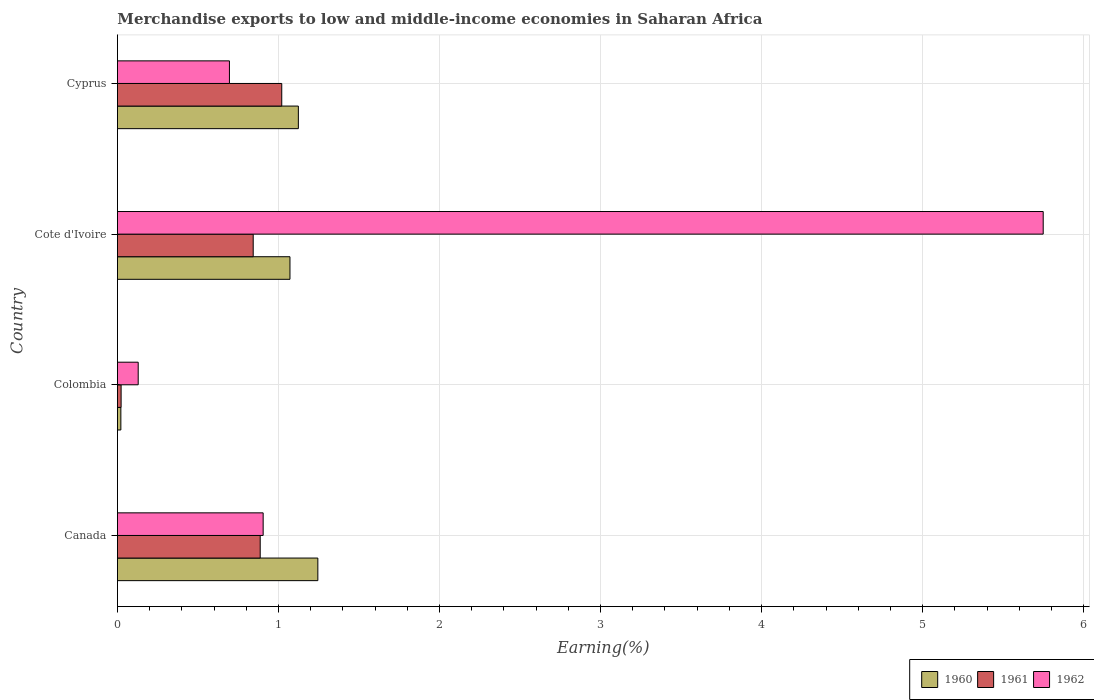Are the number of bars per tick equal to the number of legend labels?
Provide a short and direct response. Yes. Are the number of bars on each tick of the Y-axis equal?
Provide a succinct answer. Yes. How many bars are there on the 3rd tick from the bottom?
Keep it short and to the point. 3. What is the label of the 2nd group of bars from the top?
Your answer should be very brief. Cote d'Ivoire. What is the percentage of amount earned from merchandise exports in 1962 in Cote d'Ivoire?
Make the answer very short. 5.75. Across all countries, what is the maximum percentage of amount earned from merchandise exports in 1960?
Provide a short and direct response. 1.24. Across all countries, what is the minimum percentage of amount earned from merchandise exports in 1960?
Your answer should be very brief. 0.02. In which country was the percentage of amount earned from merchandise exports in 1962 minimum?
Provide a succinct answer. Colombia. What is the total percentage of amount earned from merchandise exports in 1961 in the graph?
Keep it short and to the point. 2.77. What is the difference between the percentage of amount earned from merchandise exports in 1960 in Canada and that in Colombia?
Your answer should be very brief. 1.22. What is the difference between the percentage of amount earned from merchandise exports in 1962 in Canada and the percentage of amount earned from merchandise exports in 1960 in Cote d'Ivoire?
Your response must be concise. -0.17. What is the average percentage of amount earned from merchandise exports in 1960 per country?
Provide a short and direct response. 0.87. What is the difference between the percentage of amount earned from merchandise exports in 1961 and percentage of amount earned from merchandise exports in 1960 in Canada?
Make the answer very short. -0.36. In how many countries, is the percentage of amount earned from merchandise exports in 1960 greater than 1 %?
Provide a succinct answer. 3. What is the ratio of the percentage of amount earned from merchandise exports in 1961 in Cote d'Ivoire to that in Cyprus?
Offer a terse response. 0.83. What is the difference between the highest and the second highest percentage of amount earned from merchandise exports in 1962?
Your answer should be compact. 4.84. What is the difference between the highest and the lowest percentage of amount earned from merchandise exports in 1960?
Your response must be concise. 1.22. In how many countries, is the percentage of amount earned from merchandise exports in 1961 greater than the average percentage of amount earned from merchandise exports in 1961 taken over all countries?
Offer a very short reply. 3. What does the 3rd bar from the top in Canada represents?
Provide a short and direct response. 1960. Is it the case that in every country, the sum of the percentage of amount earned from merchandise exports in 1961 and percentage of amount earned from merchandise exports in 1962 is greater than the percentage of amount earned from merchandise exports in 1960?
Provide a short and direct response. Yes. Are the values on the major ticks of X-axis written in scientific E-notation?
Keep it short and to the point. No. Does the graph contain grids?
Your answer should be compact. Yes. Where does the legend appear in the graph?
Your answer should be compact. Bottom right. What is the title of the graph?
Your answer should be very brief. Merchandise exports to low and middle-income economies in Saharan Africa. What is the label or title of the X-axis?
Offer a terse response. Earning(%). What is the label or title of the Y-axis?
Your answer should be compact. Country. What is the Earning(%) in 1960 in Canada?
Make the answer very short. 1.24. What is the Earning(%) in 1961 in Canada?
Ensure brevity in your answer.  0.89. What is the Earning(%) in 1962 in Canada?
Make the answer very short. 0.9. What is the Earning(%) in 1960 in Colombia?
Provide a succinct answer. 0.02. What is the Earning(%) in 1961 in Colombia?
Offer a very short reply. 0.02. What is the Earning(%) in 1962 in Colombia?
Provide a succinct answer. 0.13. What is the Earning(%) of 1960 in Cote d'Ivoire?
Your response must be concise. 1.07. What is the Earning(%) in 1961 in Cote d'Ivoire?
Keep it short and to the point. 0.84. What is the Earning(%) of 1962 in Cote d'Ivoire?
Offer a very short reply. 5.75. What is the Earning(%) of 1960 in Cyprus?
Make the answer very short. 1.12. What is the Earning(%) in 1961 in Cyprus?
Ensure brevity in your answer.  1.02. What is the Earning(%) in 1962 in Cyprus?
Keep it short and to the point. 0.7. Across all countries, what is the maximum Earning(%) in 1960?
Your answer should be compact. 1.24. Across all countries, what is the maximum Earning(%) of 1961?
Provide a succinct answer. 1.02. Across all countries, what is the maximum Earning(%) in 1962?
Make the answer very short. 5.75. Across all countries, what is the minimum Earning(%) in 1960?
Give a very brief answer. 0.02. Across all countries, what is the minimum Earning(%) of 1961?
Give a very brief answer. 0.02. Across all countries, what is the minimum Earning(%) in 1962?
Offer a very short reply. 0.13. What is the total Earning(%) of 1960 in the graph?
Make the answer very short. 3.46. What is the total Earning(%) in 1961 in the graph?
Ensure brevity in your answer.  2.77. What is the total Earning(%) in 1962 in the graph?
Provide a succinct answer. 7.48. What is the difference between the Earning(%) of 1960 in Canada and that in Colombia?
Give a very brief answer. 1.22. What is the difference between the Earning(%) in 1961 in Canada and that in Colombia?
Offer a terse response. 0.86. What is the difference between the Earning(%) in 1962 in Canada and that in Colombia?
Your answer should be very brief. 0.78. What is the difference between the Earning(%) of 1960 in Canada and that in Cote d'Ivoire?
Provide a succinct answer. 0.17. What is the difference between the Earning(%) in 1961 in Canada and that in Cote d'Ivoire?
Keep it short and to the point. 0.04. What is the difference between the Earning(%) in 1962 in Canada and that in Cote d'Ivoire?
Give a very brief answer. -4.84. What is the difference between the Earning(%) of 1960 in Canada and that in Cyprus?
Offer a very short reply. 0.12. What is the difference between the Earning(%) of 1961 in Canada and that in Cyprus?
Provide a short and direct response. -0.13. What is the difference between the Earning(%) of 1962 in Canada and that in Cyprus?
Your answer should be compact. 0.21. What is the difference between the Earning(%) in 1960 in Colombia and that in Cote d'Ivoire?
Offer a terse response. -1.05. What is the difference between the Earning(%) of 1961 in Colombia and that in Cote d'Ivoire?
Provide a short and direct response. -0.82. What is the difference between the Earning(%) in 1962 in Colombia and that in Cote d'Ivoire?
Give a very brief answer. -5.62. What is the difference between the Earning(%) in 1960 in Colombia and that in Cyprus?
Provide a succinct answer. -1.1. What is the difference between the Earning(%) of 1961 in Colombia and that in Cyprus?
Offer a very short reply. -1. What is the difference between the Earning(%) of 1962 in Colombia and that in Cyprus?
Give a very brief answer. -0.57. What is the difference between the Earning(%) of 1960 in Cote d'Ivoire and that in Cyprus?
Provide a short and direct response. -0.05. What is the difference between the Earning(%) of 1961 in Cote d'Ivoire and that in Cyprus?
Offer a terse response. -0.18. What is the difference between the Earning(%) of 1962 in Cote d'Ivoire and that in Cyprus?
Provide a short and direct response. 5.05. What is the difference between the Earning(%) of 1960 in Canada and the Earning(%) of 1961 in Colombia?
Ensure brevity in your answer.  1.22. What is the difference between the Earning(%) in 1960 in Canada and the Earning(%) in 1962 in Colombia?
Provide a succinct answer. 1.12. What is the difference between the Earning(%) of 1961 in Canada and the Earning(%) of 1962 in Colombia?
Your answer should be compact. 0.76. What is the difference between the Earning(%) of 1960 in Canada and the Earning(%) of 1961 in Cote d'Ivoire?
Offer a terse response. 0.4. What is the difference between the Earning(%) in 1960 in Canada and the Earning(%) in 1962 in Cote d'Ivoire?
Your answer should be very brief. -4.5. What is the difference between the Earning(%) in 1961 in Canada and the Earning(%) in 1962 in Cote d'Ivoire?
Keep it short and to the point. -4.86. What is the difference between the Earning(%) in 1960 in Canada and the Earning(%) in 1961 in Cyprus?
Provide a short and direct response. 0.22. What is the difference between the Earning(%) in 1960 in Canada and the Earning(%) in 1962 in Cyprus?
Your response must be concise. 0.55. What is the difference between the Earning(%) of 1961 in Canada and the Earning(%) of 1962 in Cyprus?
Your answer should be very brief. 0.19. What is the difference between the Earning(%) of 1960 in Colombia and the Earning(%) of 1961 in Cote d'Ivoire?
Ensure brevity in your answer.  -0.82. What is the difference between the Earning(%) of 1960 in Colombia and the Earning(%) of 1962 in Cote d'Ivoire?
Offer a very short reply. -5.73. What is the difference between the Earning(%) of 1961 in Colombia and the Earning(%) of 1962 in Cote d'Ivoire?
Ensure brevity in your answer.  -5.73. What is the difference between the Earning(%) of 1960 in Colombia and the Earning(%) of 1961 in Cyprus?
Provide a short and direct response. -1. What is the difference between the Earning(%) in 1960 in Colombia and the Earning(%) in 1962 in Cyprus?
Offer a terse response. -0.67. What is the difference between the Earning(%) in 1961 in Colombia and the Earning(%) in 1962 in Cyprus?
Your answer should be very brief. -0.67. What is the difference between the Earning(%) in 1960 in Cote d'Ivoire and the Earning(%) in 1961 in Cyprus?
Keep it short and to the point. 0.05. What is the difference between the Earning(%) of 1960 in Cote d'Ivoire and the Earning(%) of 1962 in Cyprus?
Give a very brief answer. 0.38. What is the difference between the Earning(%) of 1961 in Cote d'Ivoire and the Earning(%) of 1962 in Cyprus?
Your answer should be very brief. 0.15. What is the average Earning(%) in 1960 per country?
Make the answer very short. 0.87. What is the average Earning(%) of 1961 per country?
Provide a succinct answer. 0.69. What is the average Earning(%) of 1962 per country?
Make the answer very short. 1.87. What is the difference between the Earning(%) of 1960 and Earning(%) of 1961 in Canada?
Keep it short and to the point. 0.36. What is the difference between the Earning(%) of 1960 and Earning(%) of 1962 in Canada?
Give a very brief answer. 0.34. What is the difference between the Earning(%) of 1961 and Earning(%) of 1962 in Canada?
Your answer should be very brief. -0.02. What is the difference between the Earning(%) of 1960 and Earning(%) of 1961 in Colombia?
Ensure brevity in your answer.  -0. What is the difference between the Earning(%) in 1960 and Earning(%) in 1962 in Colombia?
Ensure brevity in your answer.  -0.11. What is the difference between the Earning(%) of 1961 and Earning(%) of 1962 in Colombia?
Ensure brevity in your answer.  -0.11. What is the difference between the Earning(%) in 1960 and Earning(%) in 1961 in Cote d'Ivoire?
Provide a short and direct response. 0.23. What is the difference between the Earning(%) in 1960 and Earning(%) in 1962 in Cote d'Ivoire?
Your answer should be very brief. -4.68. What is the difference between the Earning(%) in 1961 and Earning(%) in 1962 in Cote d'Ivoire?
Your answer should be compact. -4.91. What is the difference between the Earning(%) of 1960 and Earning(%) of 1961 in Cyprus?
Your response must be concise. 0.1. What is the difference between the Earning(%) of 1960 and Earning(%) of 1962 in Cyprus?
Offer a very short reply. 0.43. What is the difference between the Earning(%) of 1961 and Earning(%) of 1962 in Cyprus?
Provide a short and direct response. 0.32. What is the ratio of the Earning(%) of 1960 in Canada to that in Colombia?
Offer a terse response. 57.92. What is the ratio of the Earning(%) in 1961 in Canada to that in Colombia?
Your answer should be compact. 38.58. What is the ratio of the Earning(%) of 1962 in Canada to that in Colombia?
Offer a terse response. 7.01. What is the ratio of the Earning(%) of 1960 in Canada to that in Cote d'Ivoire?
Your answer should be compact. 1.16. What is the ratio of the Earning(%) of 1961 in Canada to that in Cote d'Ivoire?
Your answer should be compact. 1.05. What is the ratio of the Earning(%) of 1962 in Canada to that in Cote d'Ivoire?
Ensure brevity in your answer.  0.16. What is the ratio of the Earning(%) of 1960 in Canada to that in Cyprus?
Your response must be concise. 1.11. What is the ratio of the Earning(%) in 1961 in Canada to that in Cyprus?
Provide a short and direct response. 0.87. What is the ratio of the Earning(%) in 1962 in Canada to that in Cyprus?
Offer a terse response. 1.3. What is the ratio of the Earning(%) in 1960 in Colombia to that in Cote d'Ivoire?
Your answer should be very brief. 0.02. What is the ratio of the Earning(%) in 1961 in Colombia to that in Cote d'Ivoire?
Provide a succinct answer. 0.03. What is the ratio of the Earning(%) in 1962 in Colombia to that in Cote d'Ivoire?
Your answer should be very brief. 0.02. What is the ratio of the Earning(%) in 1960 in Colombia to that in Cyprus?
Give a very brief answer. 0.02. What is the ratio of the Earning(%) of 1961 in Colombia to that in Cyprus?
Keep it short and to the point. 0.02. What is the ratio of the Earning(%) of 1962 in Colombia to that in Cyprus?
Keep it short and to the point. 0.19. What is the ratio of the Earning(%) of 1960 in Cote d'Ivoire to that in Cyprus?
Offer a terse response. 0.95. What is the ratio of the Earning(%) of 1961 in Cote d'Ivoire to that in Cyprus?
Offer a very short reply. 0.83. What is the ratio of the Earning(%) in 1962 in Cote d'Ivoire to that in Cyprus?
Provide a short and direct response. 8.26. What is the difference between the highest and the second highest Earning(%) in 1960?
Offer a very short reply. 0.12. What is the difference between the highest and the second highest Earning(%) of 1961?
Make the answer very short. 0.13. What is the difference between the highest and the second highest Earning(%) of 1962?
Offer a terse response. 4.84. What is the difference between the highest and the lowest Earning(%) of 1960?
Offer a very short reply. 1.22. What is the difference between the highest and the lowest Earning(%) of 1962?
Make the answer very short. 5.62. 